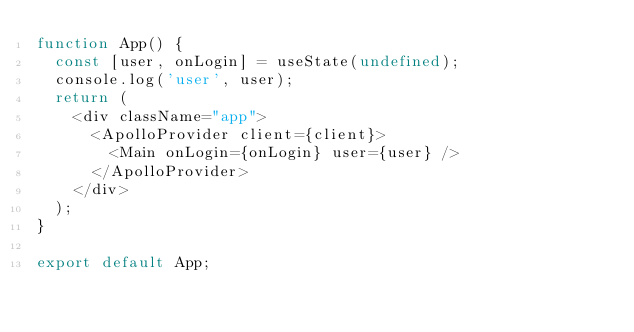Convert code to text. <code><loc_0><loc_0><loc_500><loc_500><_JavaScript_>function App() {
  const [user, onLogin] = useState(undefined);
  console.log('user', user);
  return (
    <div className="app">
      <ApolloProvider client={client}>
        <Main onLogin={onLogin} user={user} />
      </ApolloProvider>
    </div>
  );
}

export default App;
</code> 